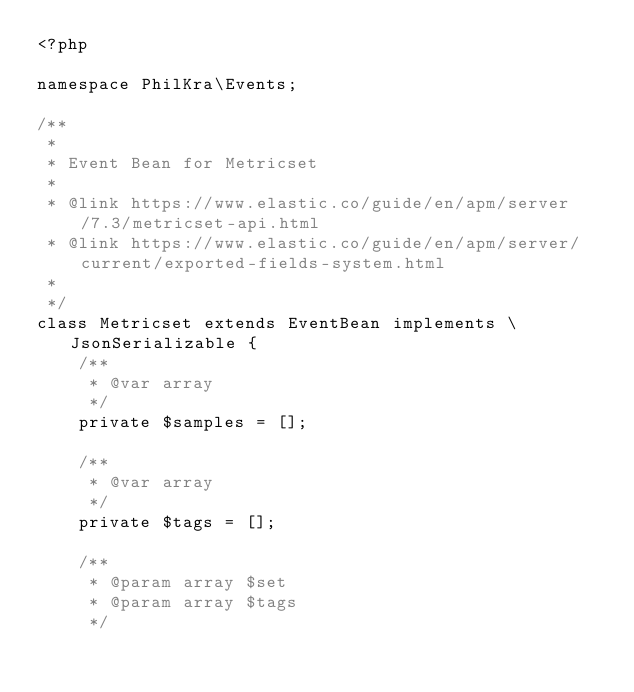Convert code to text. <code><loc_0><loc_0><loc_500><loc_500><_PHP_><?php

namespace PhilKra\Events;

/**
 *
 * Event Bean for Metricset
 *
 * @link https://www.elastic.co/guide/en/apm/server/7.3/metricset-api.html
 * @link https://www.elastic.co/guide/en/apm/server/current/exported-fields-system.html
 *
 */
class Metricset extends EventBean implements \JsonSerializable {
    /**
     * @var array
     */
    private $samples = [];

    /**
     * @var array
     */
    private $tags = [];

    /**
     * @param array $set
     * @param array $tags
     */</code> 